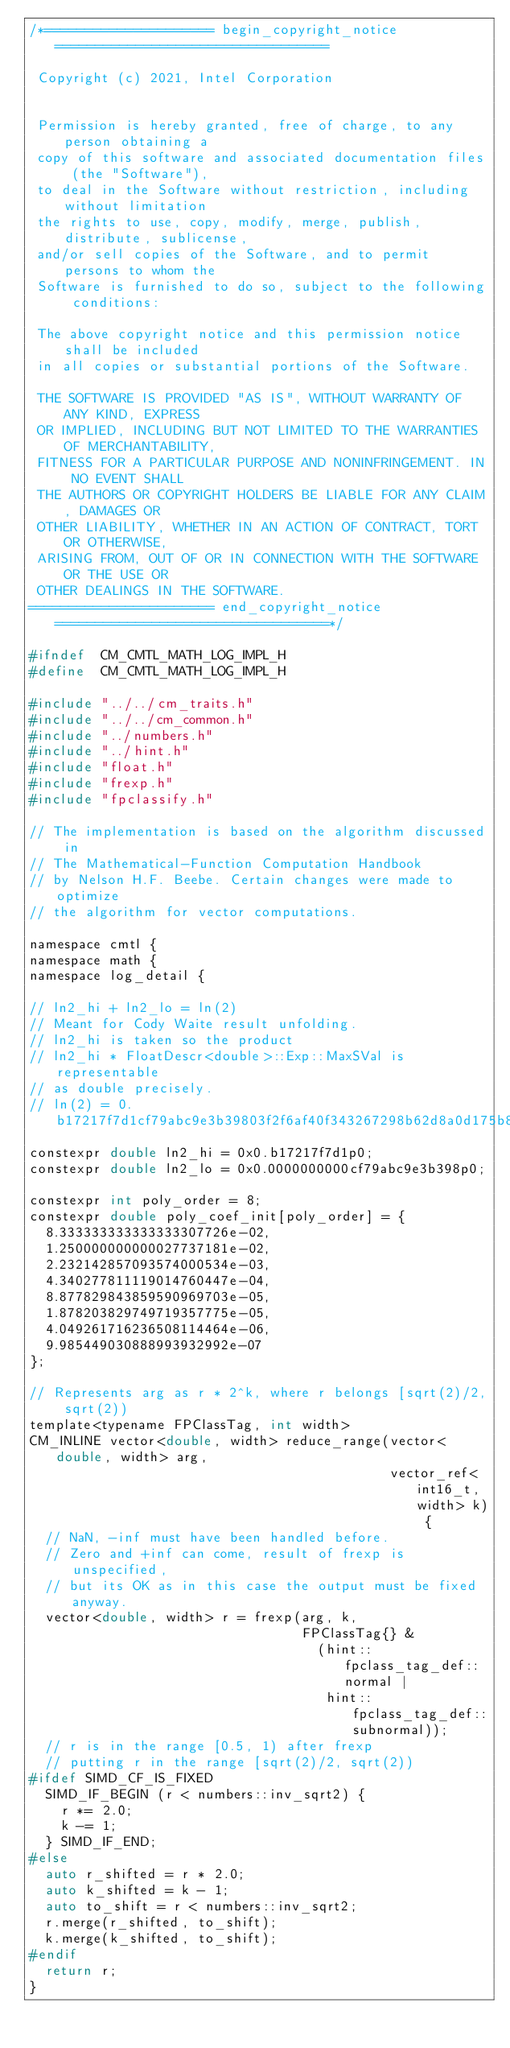Convert code to text. <code><loc_0><loc_0><loc_500><loc_500><_C_>/*===================== begin_copyright_notice ==================================

 Copyright (c) 2021, Intel Corporation


 Permission is hereby granted, free of charge, to any person obtaining a
 copy of this software and associated documentation files (the "Software"),
 to deal in the Software without restriction, including without limitation
 the rights to use, copy, modify, merge, publish, distribute, sublicense,
 and/or sell copies of the Software, and to permit persons to whom the
 Software is furnished to do so, subject to the following conditions:

 The above copyright notice and this permission notice shall be included
 in all copies or substantial portions of the Software.

 THE SOFTWARE IS PROVIDED "AS IS", WITHOUT WARRANTY OF ANY KIND, EXPRESS
 OR IMPLIED, INCLUDING BUT NOT LIMITED TO THE WARRANTIES OF MERCHANTABILITY,
 FITNESS FOR A PARTICULAR PURPOSE AND NONINFRINGEMENT. IN NO EVENT SHALL
 THE AUTHORS OR COPYRIGHT HOLDERS BE LIABLE FOR ANY CLAIM, DAMAGES OR
 OTHER LIABILITY, WHETHER IN AN ACTION OF CONTRACT, TORT OR OTHERWISE,
 ARISING FROM, OUT OF OR IN CONNECTION WITH THE SOFTWARE OR THE USE OR
 OTHER DEALINGS IN THE SOFTWARE.
======================= end_copyright_notice ==================================*/

#ifndef  CM_CMTL_MATH_LOG_IMPL_H
#define  CM_CMTL_MATH_LOG_IMPL_H

#include "../../cm_traits.h"
#include "../../cm_common.h"
#include "../numbers.h"
#include "../hint.h"
#include "float.h"
#include "frexp.h"
#include "fpclassify.h"

// The implementation is based on the algorithm discussed in
// The Mathematical-Function Computation Handbook
// by Nelson H.F. Beebe. Certain changes were made to optimize
// the algorithm for vector computations.

namespace cmtl {
namespace math {
namespace log_detail {

// ln2_hi + ln2_lo = ln(2)
// Meant for Cody Waite result unfolding.
// ln2_hi is taken so the product
// ln2_hi * FloatDescr<double>::Exp::MaxSVal is representable
// as double precisely.
// ln(2) = 0.b17217f7d1cf79abc9e3b39803f2f6af40f343267298b62d8a0d175b8baafa
constexpr double ln2_hi = 0x0.b17217f7d1p0;
constexpr double ln2_lo = 0x0.0000000000cf79abc9e3b398p0;

constexpr int poly_order = 8;
constexpr double poly_coef_init[poly_order] = {
  8.333333333333333307726e-02,
  1.250000000000027737181e-02,
  2.232142857093574000534e-03,
  4.340277811119014760447e-04,
  8.877829843859590969703e-05,
  1.878203829749719357775e-05,
  4.049261716236508114464e-06,
  9.985449030888993932992e-07
};

// Represents arg as r * 2^k, where r belongs [sqrt(2)/2, sqrt(2))
template<typename FPClassTag, int width>
CM_INLINE vector<double, width> reduce_range(vector<double, width> arg,
                                             vector_ref<int16_t, width> k) {
  // NaN, -inf must have been handled before.
  // Zero and +inf can come, result of frexp is unspecified,
  // but its OK as in this case the output must be fixed anyway.
  vector<double, width> r = frexp(arg, k,
                                  FPClassTag{} &
                                    (hint::fpclass_tag_def::normal |
                                     hint::fpclass_tag_def::subnormal));
  // r is in the range [0.5, 1) after frexp
  // putting r in the range [sqrt(2)/2, sqrt(2))
#ifdef SIMD_CF_IS_FIXED
  SIMD_IF_BEGIN (r < numbers::inv_sqrt2) {
    r *= 2.0;
    k -= 1;
  } SIMD_IF_END;
#else
  auto r_shifted = r * 2.0;
  auto k_shifted = k - 1;
  auto to_shift = r < numbers::inv_sqrt2;
  r.merge(r_shifted, to_shift);
  k.merge(k_shifted, to_shift);
#endif
  return r;
}
</code> 